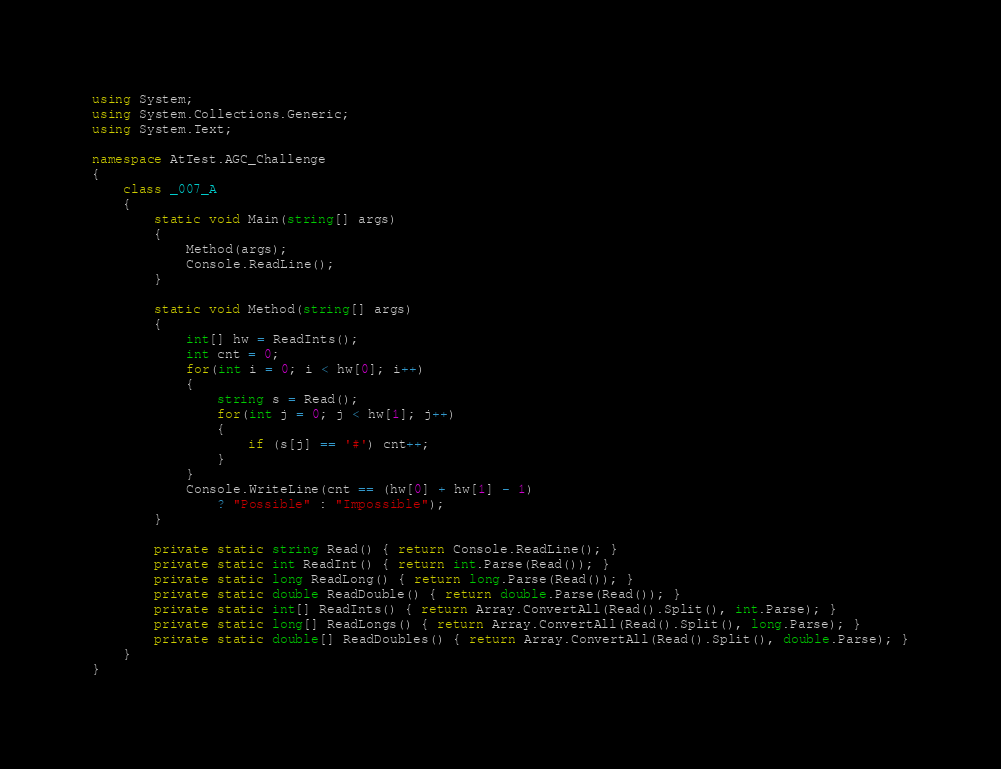Convert code to text. <code><loc_0><loc_0><loc_500><loc_500><_C#_>using System;
using System.Collections.Generic;
using System.Text;

namespace AtTest.AGC_Challenge
{
    class _007_A
    {
        static void Main(string[] args)
        {
            Method(args);
            Console.ReadLine();
        }

        static void Method(string[] args)
        {
            int[] hw = ReadInts();
            int cnt = 0;
            for(int i = 0; i < hw[0]; i++)
            {
                string s = Read();
                for(int j = 0; j < hw[1]; j++)
                {
                    if (s[j] == '#') cnt++;
                }
            }
            Console.WriteLine(cnt == (hw[0] + hw[1] - 1)
                ? "Possible" : "Impossible");
        }

        private static string Read() { return Console.ReadLine(); }
        private static int ReadInt() { return int.Parse(Read()); }
        private static long ReadLong() { return long.Parse(Read()); }
        private static double ReadDouble() { return double.Parse(Read()); }
        private static int[] ReadInts() { return Array.ConvertAll(Read().Split(), int.Parse); }
        private static long[] ReadLongs() { return Array.ConvertAll(Read().Split(), long.Parse); }
        private static double[] ReadDoubles() { return Array.ConvertAll(Read().Split(), double.Parse); }
    }
}
</code> 